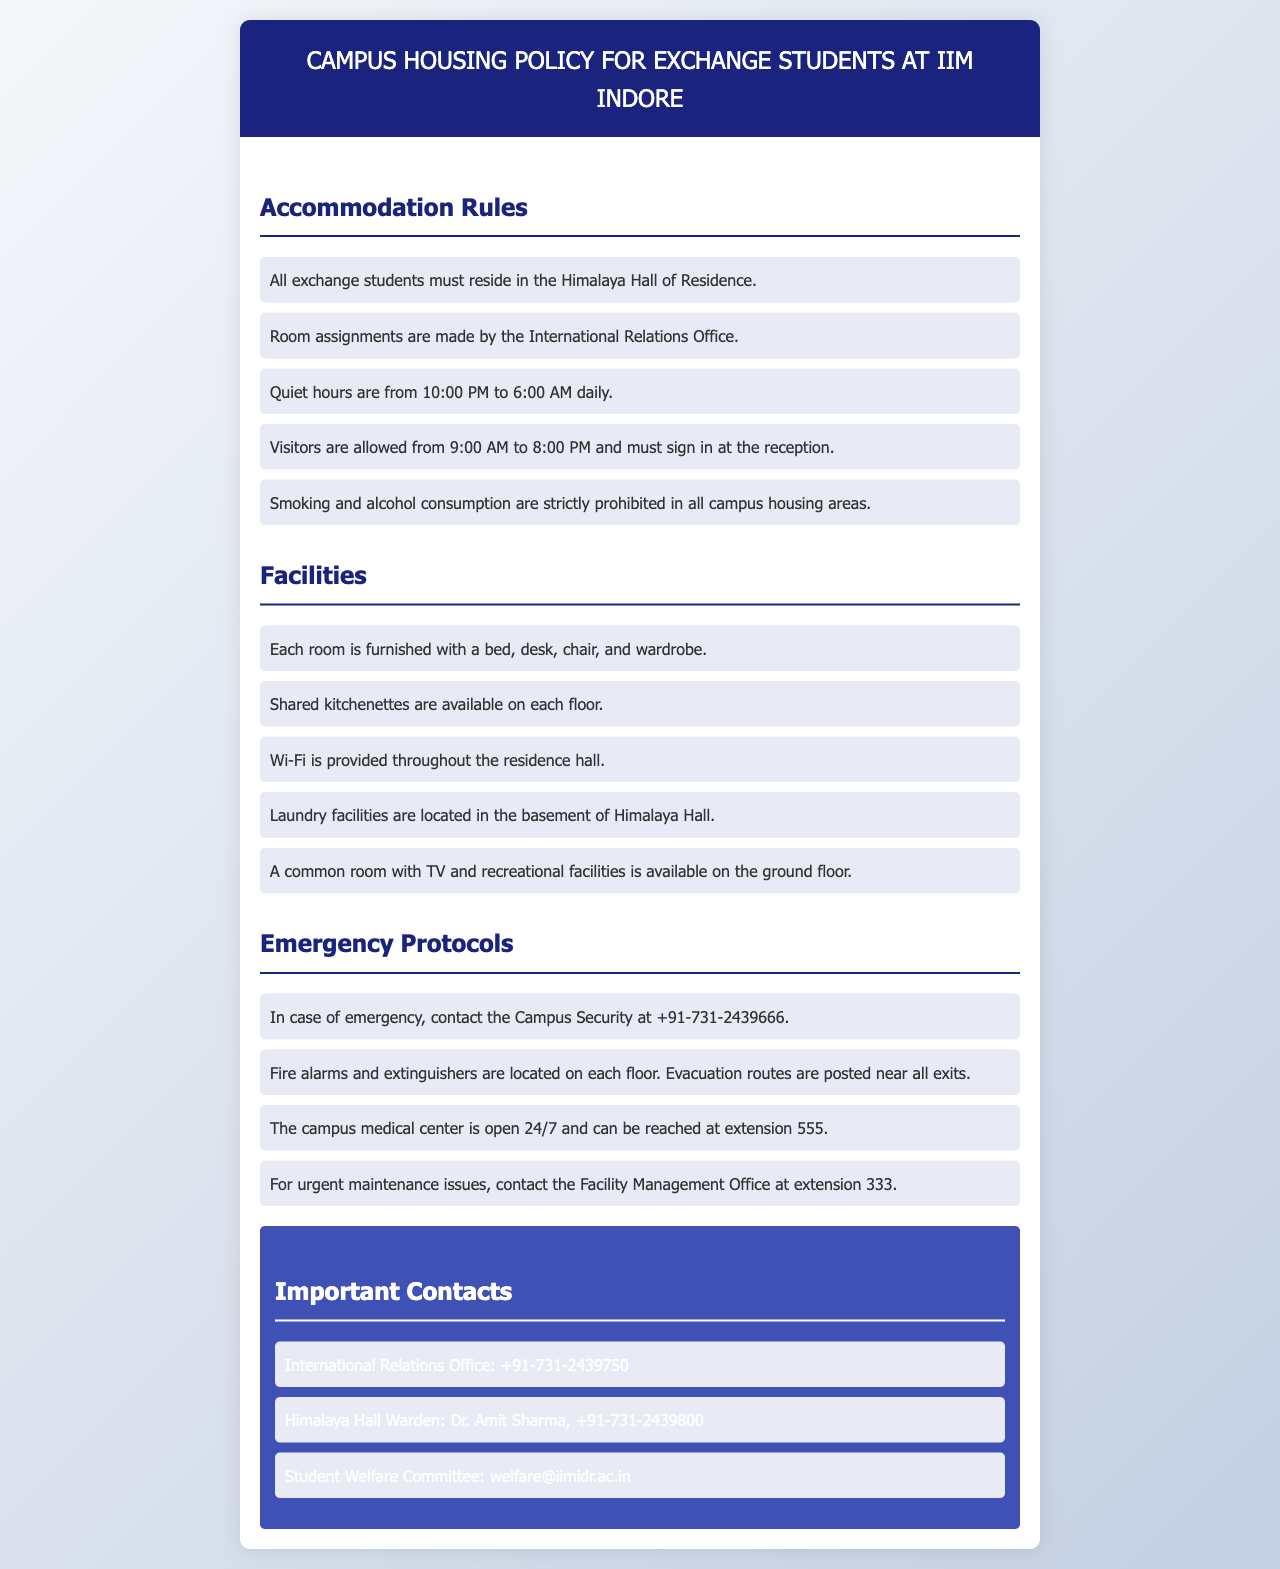What is the name of the residence hall for exchange students? The document specifies that all exchange students must reside in the Himalaya Hall of Residence.
Answer: Himalaya Hall of Residence What are the quiet hours in the campus housing? The quiet hours are mentioned to be from 10:00 PM to 6:00 AM daily.
Answer: 10:00 PM to 6:00 AM Who is the Warden of Himalaya Hall? The document names Dr. Amit Sharma as the Warden of Himalaya Hall.
Answer: Dr. Amit Sharma What is provided in each room? The document lists that each room is furnished with a bed, desk, chair, and wardrobe.
Answer: Bed, desk, chair, wardrobe What is the contact number for the Campus Security in case of emergency? The document provides +91-731-2439666 as the contact number for Campus Security.
Answer: +91-731-2439666 During what hours are visitors allowed? According to the document, visitors are allowed from 9:00 AM to 8:00 PM.
Answer: 9:00 AM to 8:00 PM Where are laundry facilities located? The document states that laundry facilities are located in the basement of Himalaya Hall.
Answer: Basement of Himalaya Hall What type of protocols are included in the document? The document outlines emergency protocols to be followed in case of an emergency.
Answer: Emergency protocols What should be done for urgent maintenance issues? The document instructs to contact the Facility Management Office at extension 333 for urgent maintenance issues.
Answer: Extension 333 